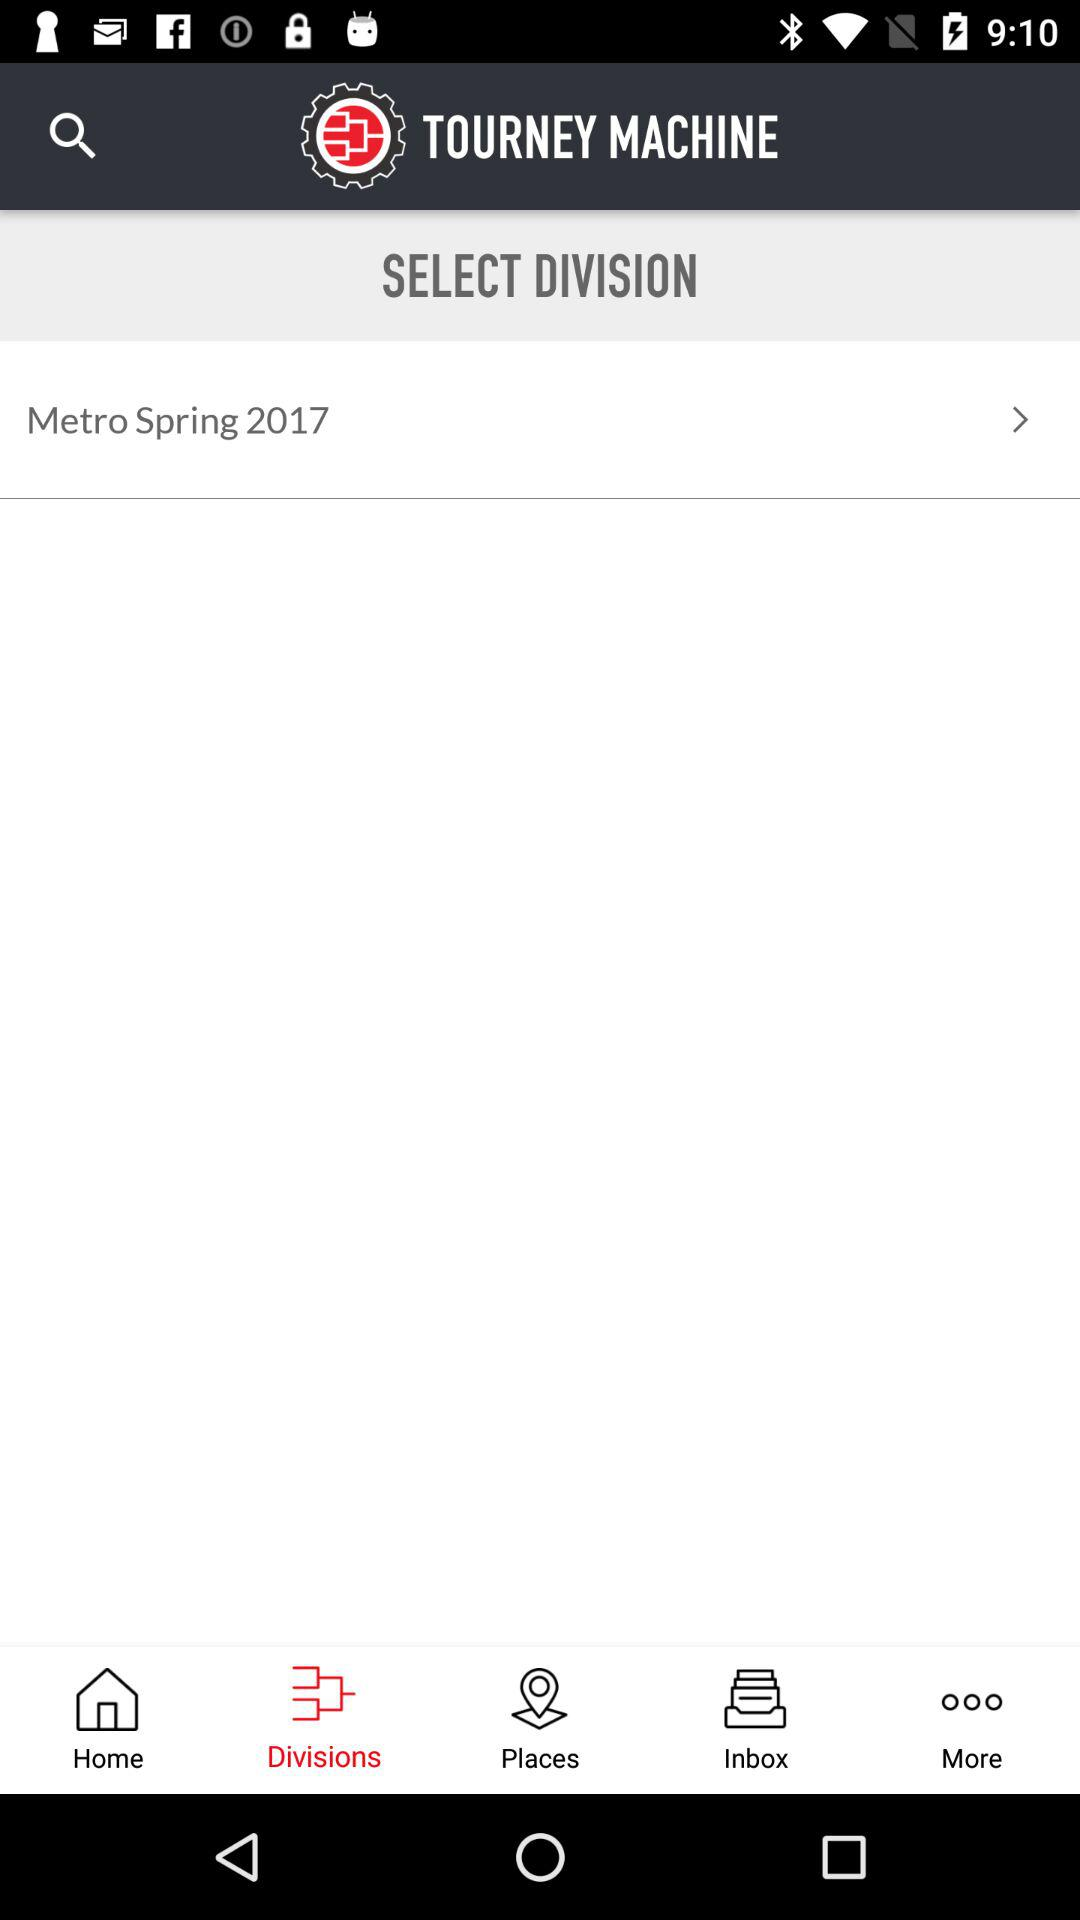What is the year of Metro Spring? The year is 2017. 